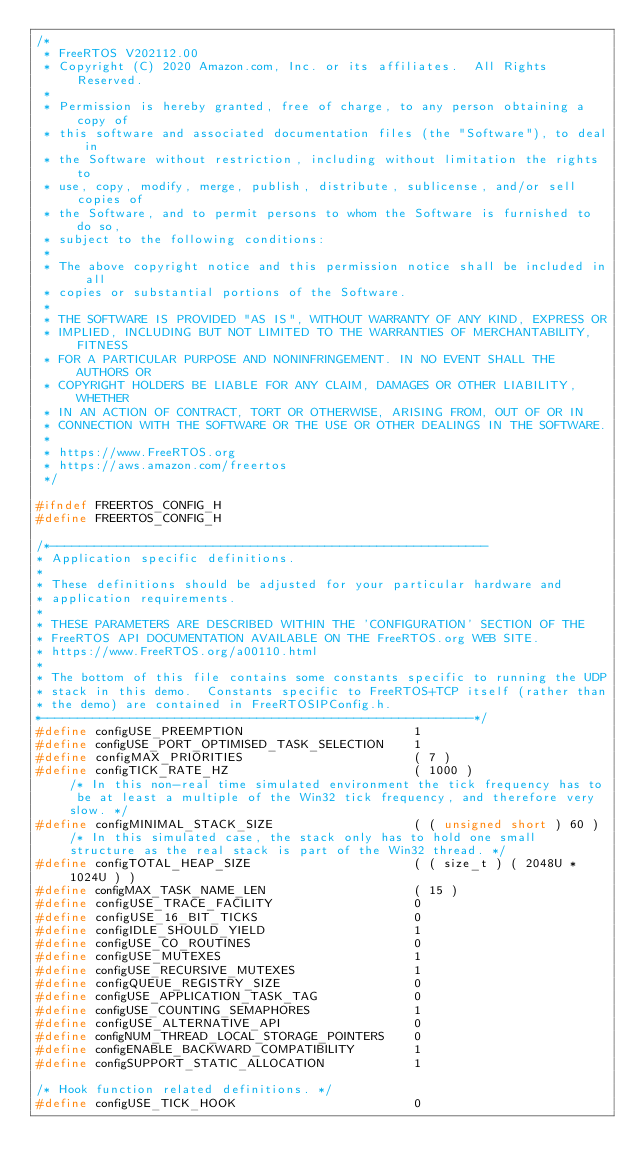Convert code to text. <code><loc_0><loc_0><loc_500><loc_500><_C_>/*
 * FreeRTOS V202112.00
 * Copyright (C) 2020 Amazon.com, Inc. or its affiliates.  All Rights Reserved.
 *
 * Permission is hereby granted, free of charge, to any person obtaining a copy of
 * this software and associated documentation files (the "Software"), to deal in
 * the Software without restriction, including without limitation the rights to
 * use, copy, modify, merge, publish, distribute, sublicense, and/or sell copies of
 * the Software, and to permit persons to whom the Software is furnished to do so,
 * subject to the following conditions:
 *
 * The above copyright notice and this permission notice shall be included in all
 * copies or substantial portions of the Software.
 *
 * THE SOFTWARE IS PROVIDED "AS IS", WITHOUT WARRANTY OF ANY KIND, EXPRESS OR
 * IMPLIED, INCLUDING BUT NOT LIMITED TO THE WARRANTIES OF MERCHANTABILITY, FITNESS
 * FOR A PARTICULAR PURPOSE AND NONINFRINGEMENT. IN NO EVENT SHALL THE AUTHORS OR
 * COPYRIGHT HOLDERS BE LIABLE FOR ANY CLAIM, DAMAGES OR OTHER LIABILITY, WHETHER
 * IN AN ACTION OF CONTRACT, TORT OR OTHERWISE, ARISING FROM, OUT OF OR IN
 * CONNECTION WITH THE SOFTWARE OR THE USE OR OTHER DEALINGS IN THE SOFTWARE.
 *
 * https://www.FreeRTOS.org
 * https://aws.amazon.com/freertos
 */

#ifndef FREERTOS_CONFIG_H
#define FREERTOS_CONFIG_H

/*-----------------------------------------------------------
* Application specific definitions.
*
* These definitions should be adjusted for your particular hardware and
* application requirements.
*
* THESE PARAMETERS ARE DESCRIBED WITHIN THE 'CONFIGURATION' SECTION OF THE
* FreeRTOS API DOCUMENTATION AVAILABLE ON THE FreeRTOS.org WEB SITE.
* https://www.FreeRTOS.org/a00110.html
*
* The bottom of this file contains some constants specific to running the UDP
* stack in this demo.  Constants specific to FreeRTOS+TCP itself (rather than
* the demo) are contained in FreeRTOSIPConfig.h.
*----------------------------------------------------------*/
#define configUSE_PREEMPTION                       1
#define configUSE_PORT_OPTIMISED_TASK_SELECTION    1
#define configMAX_PRIORITIES                       ( 7 )
#define configTICK_RATE_HZ                         ( 1000 )                  /* In this non-real time simulated environment the tick frequency has to be at least a multiple of the Win32 tick frequency, and therefore very slow. */
#define configMINIMAL_STACK_SIZE                   ( ( unsigned short ) 60 ) /* In this simulated case, the stack only has to hold one small structure as the real stack is part of the Win32 thread. */
#define configTOTAL_HEAP_SIZE                      ( ( size_t ) ( 2048U * 1024U ) )
#define configMAX_TASK_NAME_LEN                    ( 15 )
#define configUSE_TRACE_FACILITY                   0
#define configUSE_16_BIT_TICKS                     0
#define configIDLE_SHOULD_YIELD                    1
#define configUSE_CO_ROUTINES                      0
#define configUSE_MUTEXES                          1
#define configUSE_RECURSIVE_MUTEXES                1
#define configQUEUE_REGISTRY_SIZE                  0
#define configUSE_APPLICATION_TASK_TAG             0
#define configUSE_COUNTING_SEMAPHORES              1
#define configUSE_ALTERNATIVE_API                  0
#define configNUM_THREAD_LOCAL_STORAGE_POINTERS    0
#define configENABLE_BACKWARD_COMPATIBILITY        1
#define configSUPPORT_STATIC_ALLOCATION            1

/* Hook function related definitions. */
#define configUSE_TICK_HOOK                        0</code> 